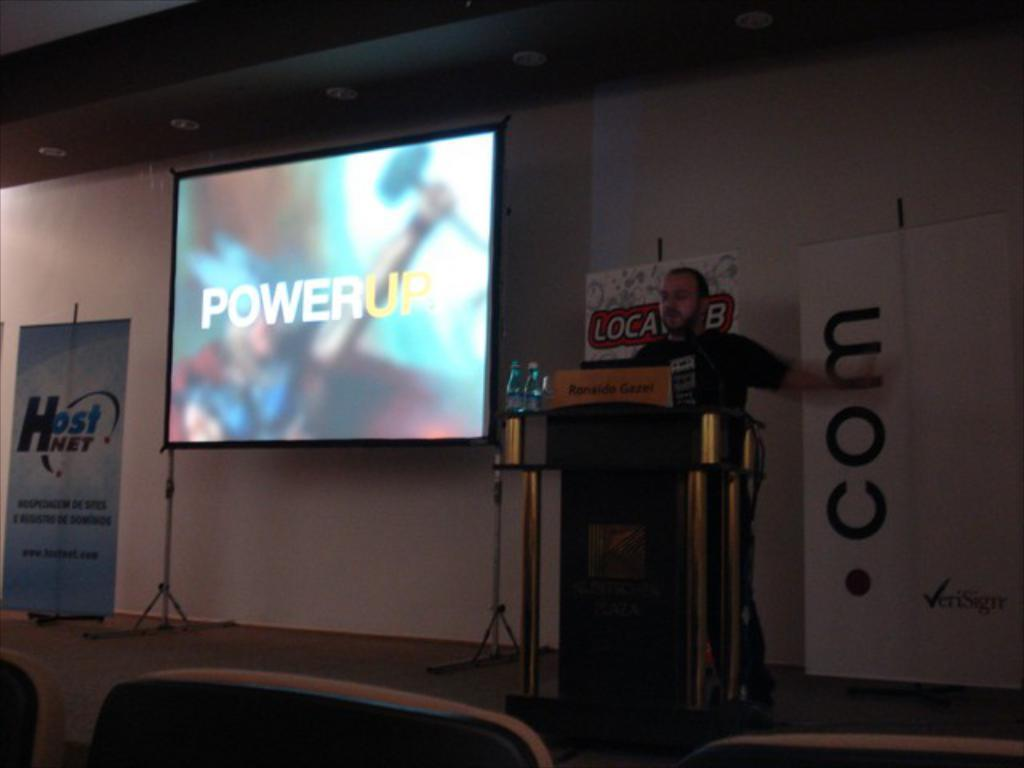<image>
Present a compact description of the photo's key features. A man behind a podium stands next to a screen which reads "Power Up" 